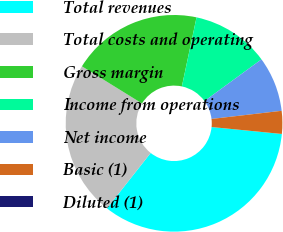Convert chart. <chart><loc_0><loc_0><loc_500><loc_500><pie_chart><fcel>Total revenues<fcel>Total costs and operating<fcel>Gross margin<fcel>Income from operations<fcel>Net income<fcel>Basic (1)<fcel>Diluted (1)<nl><fcel>34.07%<fcel>23.19%<fcel>19.51%<fcel>11.62%<fcel>8.21%<fcel>3.41%<fcel>0.0%<nl></chart> 